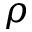Convert formula to latex. <formula><loc_0><loc_0><loc_500><loc_500>\rho</formula> 